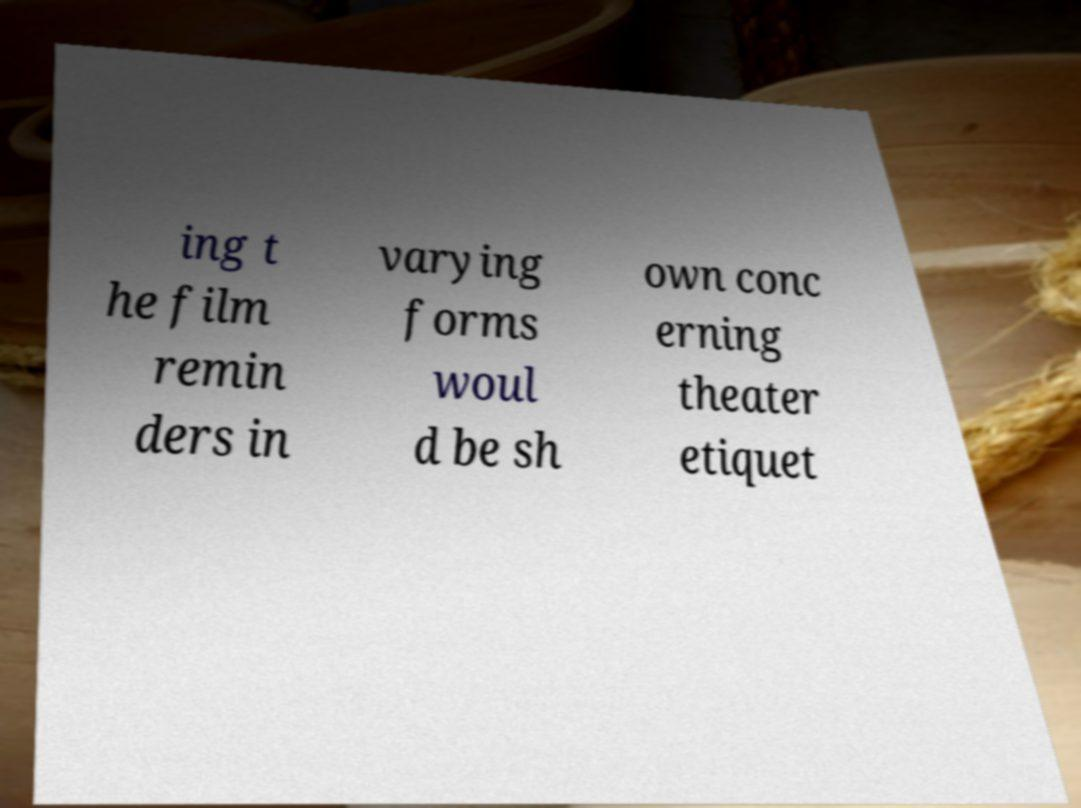Could you extract and type out the text from this image? ing t he film remin ders in varying forms woul d be sh own conc erning theater etiquet 